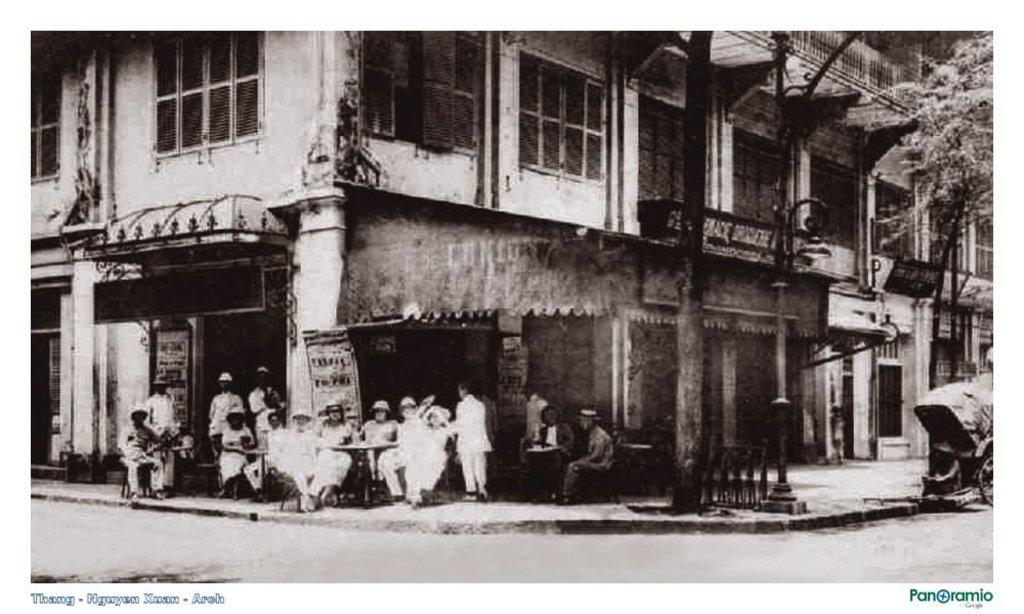In one or two sentences, can you explain what this image depicts? This is a black and white picture, there is a building in the back with few people sitting in front of it on chairs and there are trees on the right side with a road in front of it. 